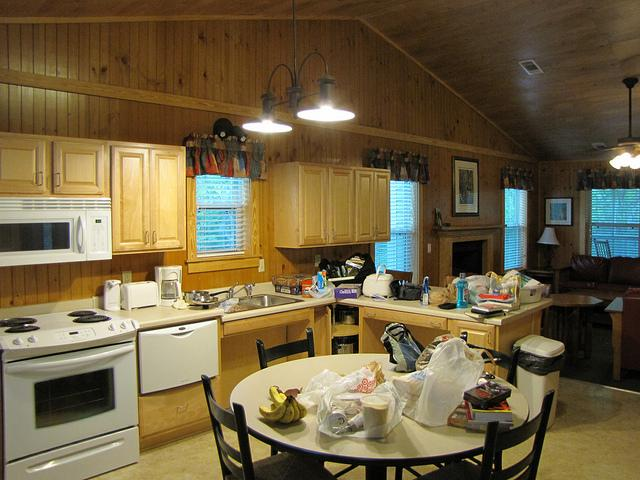What did the occupants of this home likely just get done doing?

Choices:
A) library visit
B) school
C) swimming
D) shop shop 